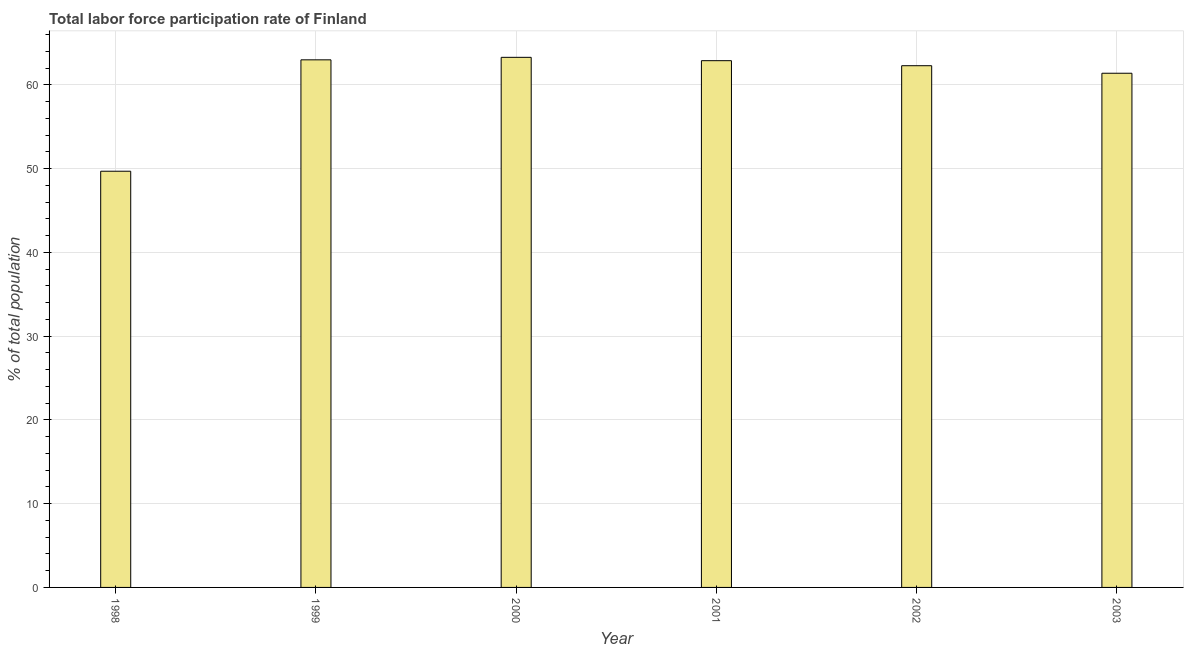Does the graph contain any zero values?
Provide a succinct answer. No. What is the title of the graph?
Your response must be concise. Total labor force participation rate of Finland. What is the label or title of the Y-axis?
Offer a terse response. % of total population. What is the total labor force participation rate in 2001?
Provide a succinct answer. 62.9. Across all years, what is the maximum total labor force participation rate?
Keep it short and to the point. 63.3. Across all years, what is the minimum total labor force participation rate?
Give a very brief answer. 49.7. In which year was the total labor force participation rate maximum?
Offer a very short reply. 2000. In which year was the total labor force participation rate minimum?
Ensure brevity in your answer.  1998. What is the sum of the total labor force participation rate?
Your answer should be very brief. 362.6. What is the difference between the total labor force participation rate in 1999 and 2000?
Make the answer very short. -0.3. What is the average total labor force participation rate per year?
Provide a short and direct response. 60.43. What is the median total labor force participation rate?
Ensure brevity in your answer.  62.6. In how many years, is the total labor force participation rate greater than 60 %?
Your response must be concise. 5. What is the ratio of the total labor force participation rate in 2001 to that in 2003?
Your answer should be very brief. 1.02. Is the total labor force participation rate in 2000 less than that in 2002?
Make the answer very short. No. Is the difference between the total labor force participation rate in 1998 and 2002 greater than the difference between any two years?
Your response must be concise. No. What is the difference between the highest and the second highest total labor force participation rate?
Offer a terse response. 0.3. What is the difference between the highest and the lowest total labor force participation rate?
Make the answer very short. 13.6. How many bars are there?
Your response must be concise. 6. How many years are there in the graph?
Keep it short and to the point. 6. What is the % of total population in 1998?
Ensure brevity in your answer.  49.7. What is the % of total population of 2000?
Provide a short and direct response. 63.3. What is the % of total population of 2001?
Give a very brief answer. 62.9. What is the % of total population of 2002?
Offer a very short reply. 62.3. What is the % of total population in 2003?
Offer a very short reply. 61.4. What is the difference between the % of total population in 1998 and 2001?
Provide a succinct answer. -13.2. What is the difference between the % of total population in 1998 and 2002?
Provide a short and direct response. -12.6. What is the difference between the % of total population in 1998 and 2003?
Give a very brief answer. -11.7. What is the difference between the % of total population in 1999 and 2001?
Make the answer very short. 0.1. What is the difference between the % of total population in 1999 and 2003?
Ensure brevity in your answer.  1.6. What is the difference between the % of total population in 2000 and 2002?
Make the answer very short. 1. What is the difference between the % of total population in 2002 and 2003?
Your answer should be very brief. 0.9. What is the ratio of the % of total population in 1998 to that in 1999?
Offer a very short reply. 0.79. What is the ratio of the % of total population in 1998 to that in 2000?
Ensure brevity in your answer.  0.79. What is the ratio of the % of total population in 1998 to that in 2001?
Offer a very short reply. 0.79. What is the ratio of the % of total population in 1998 to that in 2002?
Ensure brevity in your answer.  0.8. What is the ratio of the % of total population in 1998 to that in 2003?
Offer a very short reply. 0.81. What is the ratio of the % of total population in 1999 to that in 2000?
Ensure brevity in your answer.  0.99. What is the ratio of the % of total population in 2000 to that in 2003?
Give a very brief answer. 1.03. What is the ratio of the % of total population in 2002 to that in 2003?
Provide a succinct answer. 1.01. 